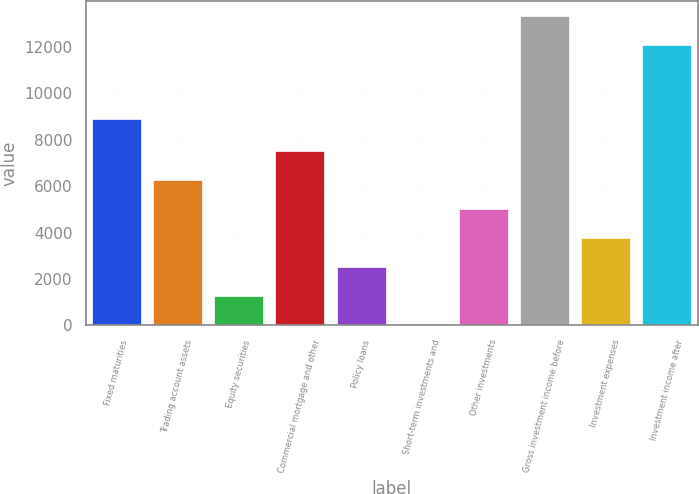Convert chart to OTSL. <chart><loc_0><loc_0><loc_500><loc_500><bar_chart><fcel>Fixed maturities<fcel>Trading account assets<fcel>Equity securities<fcel>Commercial mortgage and other<fcel>Policy loans<fcel>Short-term investments and<fcel>Other investments<fcel>Gross investment income before<fcel>Investment expenses<fcel>Investment income after<nl><fcel>8876<fcel>6249.5<fcel>1284.3<fcel>7490.8<fcel>2525.6<fcel>43<fcel>5008.2<fcel>13303.3<fcel>3766.9<fcel>12062<nl></chart> 